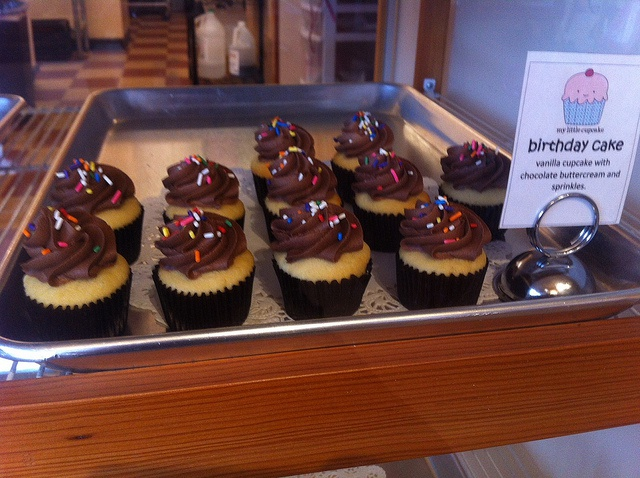Describe the objects in this image and their specific colors. I can see cake in navy, black, maroon, tan, and brown tones, cake in navy, black, maroon, tan, and gray tones, cake in navy, black, maroon, olive, and tan tones, cake in navy, black, maroon, tan, and olive tones, and cake in navy, black, maroon, and olive tones in this image. 